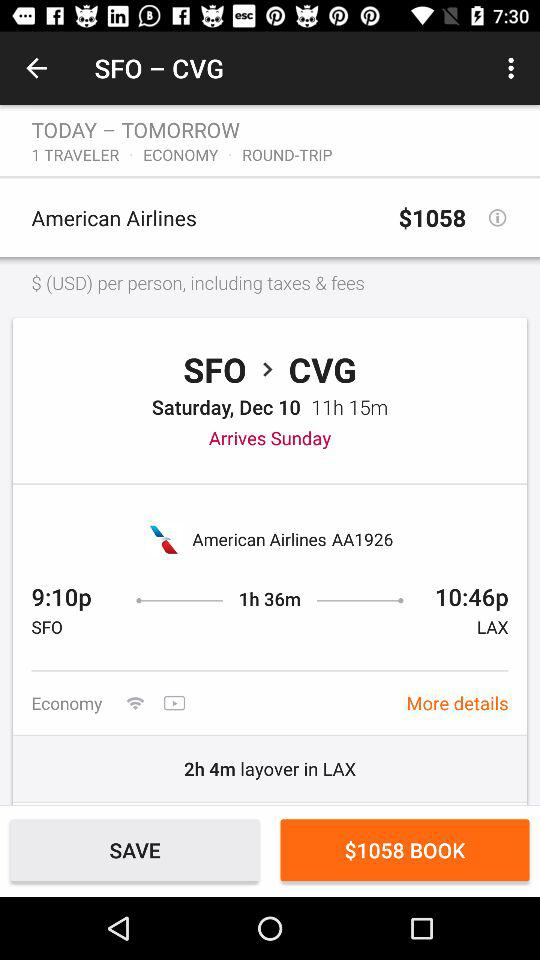What is the layover time at LAX? The layover time at LAX is 2 hours 4 minutes. 